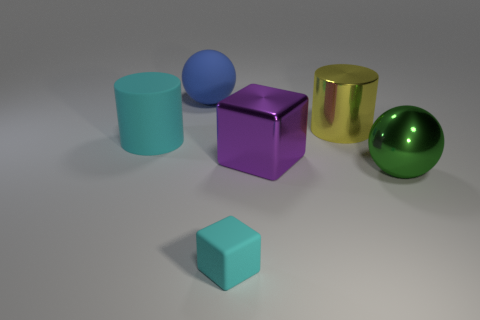What is the size of the rubber cube?
Provide a succinct answer. Small. What shape is the large cyan object?
Provide a short and direct response. Cylinder. Is the color of the large cylinder left of the tiny cyan cube the same as the small thing?
Make the answer very short. Yes. There is another thing that is the same shape as the big purple metal thing; what size is it?
Give a very brief answer. Small. There is a big cylinder that is right of the cyan thing that is behind the small rubber cube; is there a big cyan cylinder on the left side of it?
Provide a short and direct response. Yes. There is a block behind the large green shiny sphere; what is it made of?
Offer a terse response. Metal. What number of tiny objects are cylinders or purple cylinders?
Offer a terse response. 0. There is a cylinder that is left of the blue sphere; is it the same size as the large cube?
Make the answer very short. Yes. How many other objects are there of the same color as the metallic cube?
Your answer should be compact. 0. What is the yellow object made of?
Your answer should be compact. Metal. 